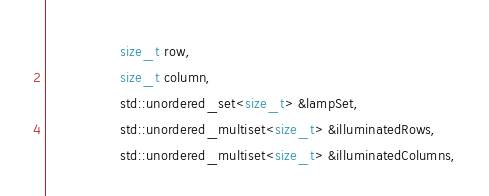Convert code to text. <code><loc_0><loc_0><loc_500><loc_500><_C++_>                  size_t row,
                  size_t column,
                  std::unordered_set<size_t> &lampSet,
                  std::unordered_multiset<size_t> &illuminatedRows,
                  std::unordered_multiset<size_t> &illuminatedColumns,</code> 